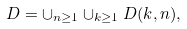<formula> <loc_0><loc_0><loc_500><loc_500>D = \cup _ { n \geq 1 } \cup _ { k \geq 1 } D ( k , n ) ,</formula> 